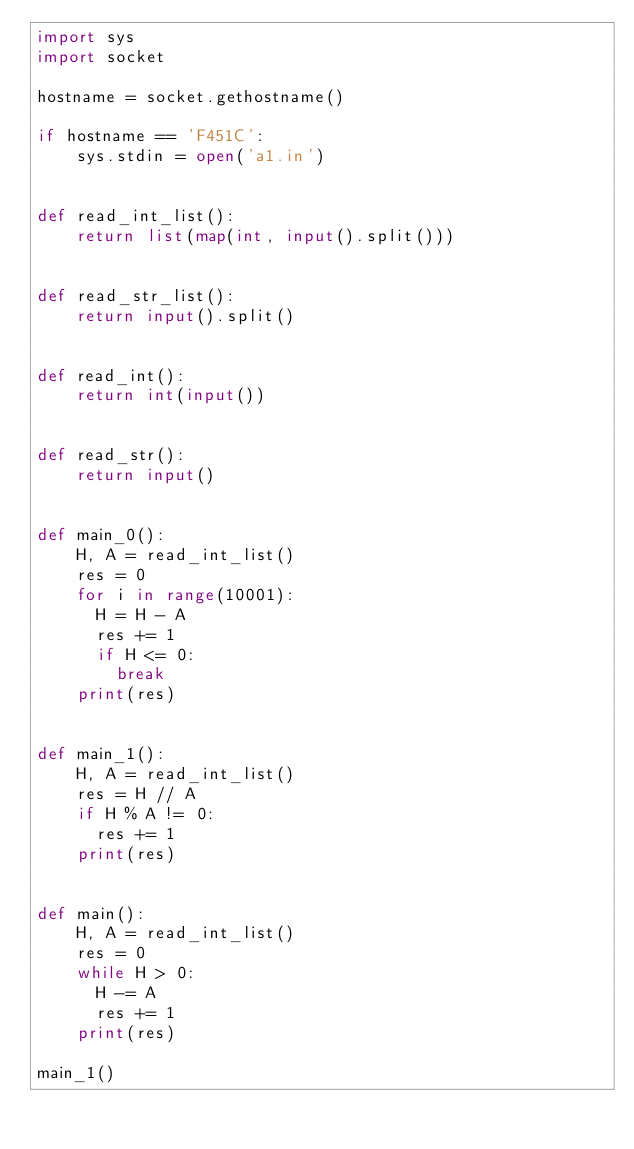Convert code to text. <code><loc_0><loc_0><loc_500><loc_500><_Python_>import sys
import socket

hostname = socket.gethostname()

if hostname == 'F451C':
    sys.stdin = open('a1.in')


def read_int_list():
    return list(map(int, input().split()))


def read_str_list():
    return input().split()


def read_int():
    return int(input())


def read_str():
    return input()


def main_0():
    H, A = read_int_list()
    res = 0
    for i in range(10001):
      H = H - A
      res += 1
      if H <= 0:
        break
    print(res)


def main_1():
    H, A = read_int_list()
    res = H // A
    if H % A != 0:
      res += 1
    print(res)


def main():
    H, A = read_int_list()
    res = 0
    while H > 0:
      H -= A
      res += 1
    print(res)

main_1()
</code> 